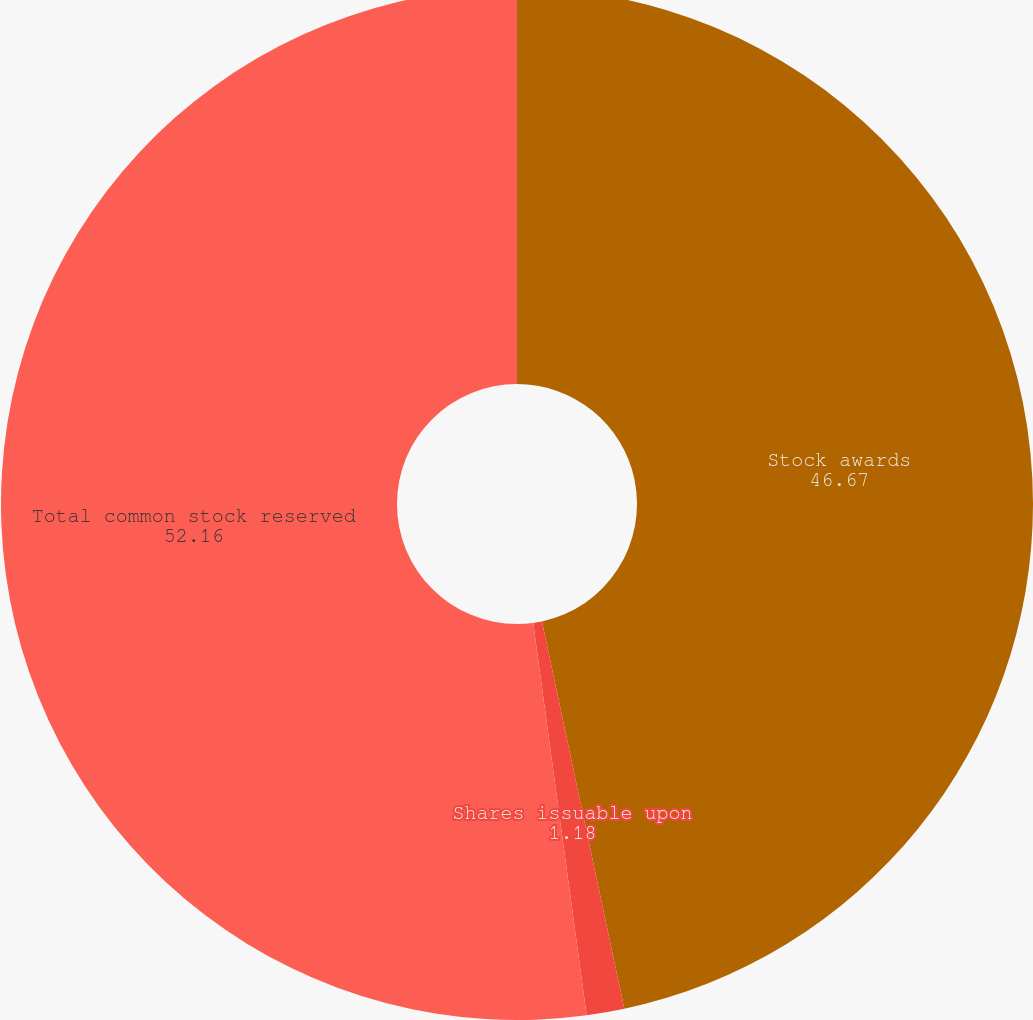Convert chart. <chart><loc_0><loc_0><loc_500><loc_500><pie_chart><fcel>Stock awards<fcel>Shares issuable upon<fcel>Total common stock reserved<nl><fcel>46.67%<fcel>1.18%<fcel>52.16%<nl></chart> 